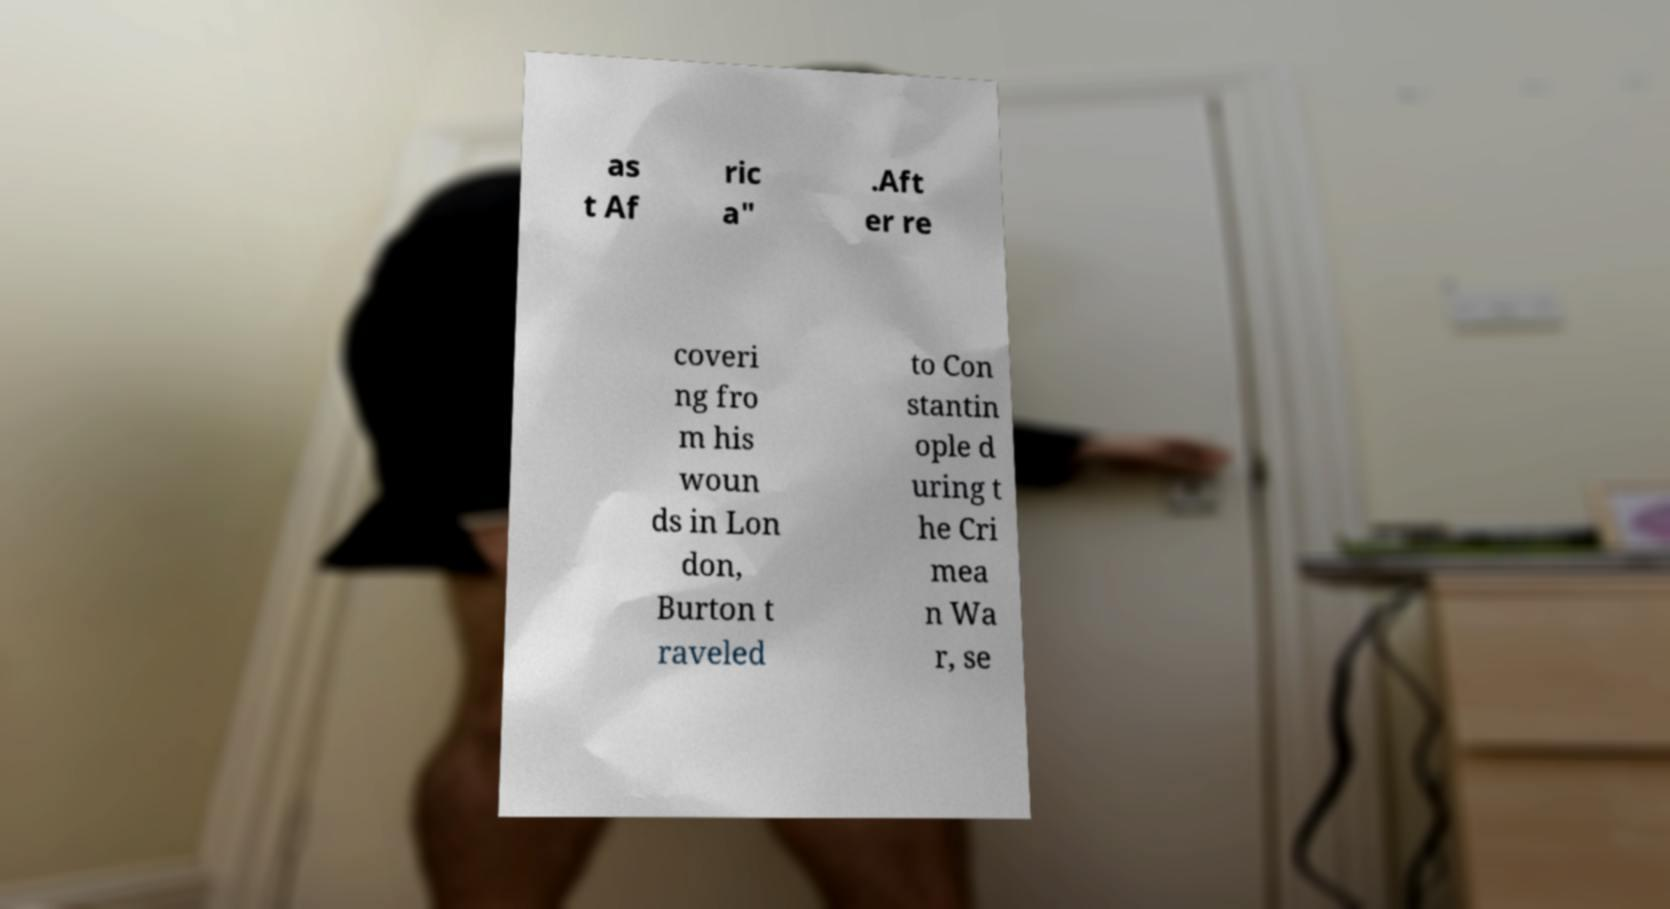Please identify and transcribe the text found in this image. as t Af ric a" .Aft er re coveri ng fro m his woun ds in Lon don, Burton t raveled to Con stantin ople d uring t he Cri mea n Wa r, se 